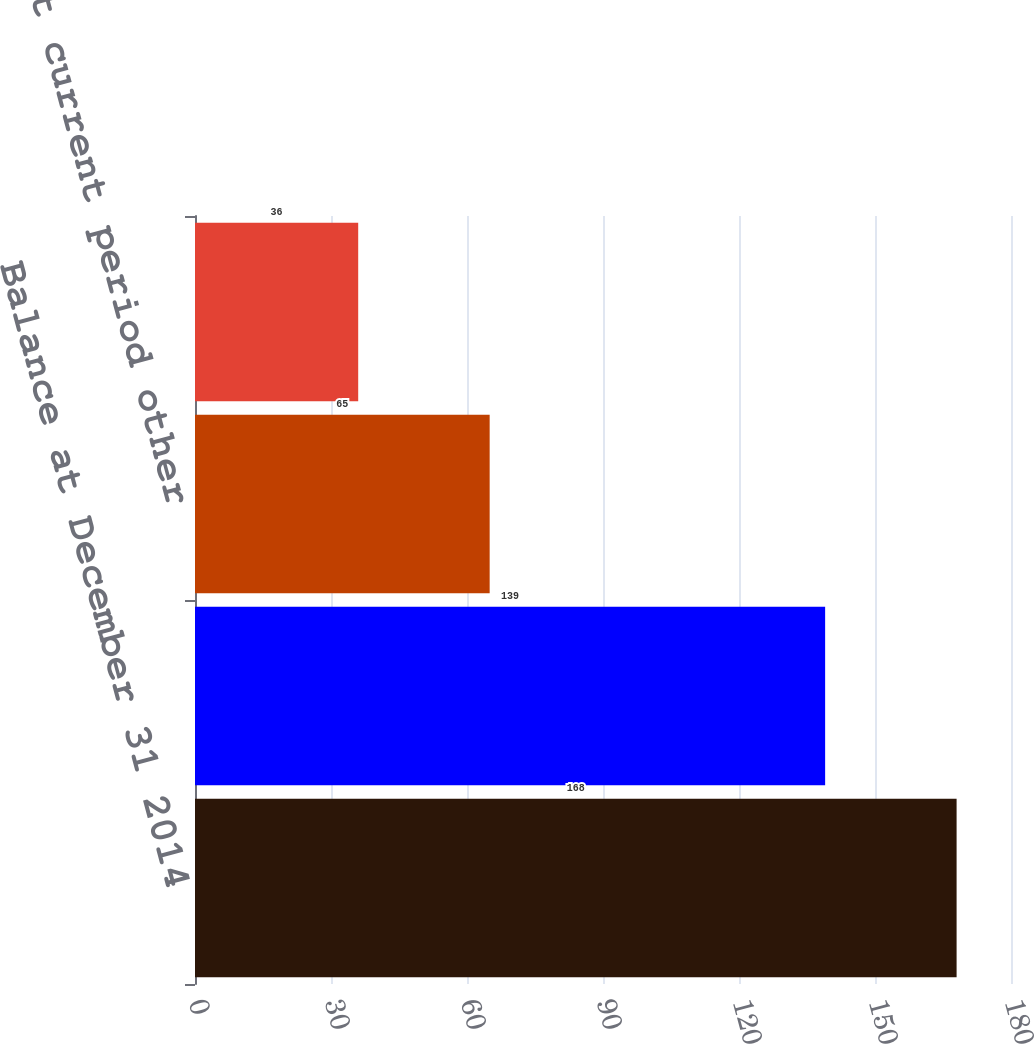Convert chart to OTSL. <chart><loc_0><loc_0><loc_500><loc_500><bar_chart><fcel>Balance at December 31 2014<fcel>Other comprehensive income<fcel>Net current period other<fcel>Balance at December 31 2015<nl><fcel>168<fcel>139<fcel>65<fcel>36<nl></chart> 